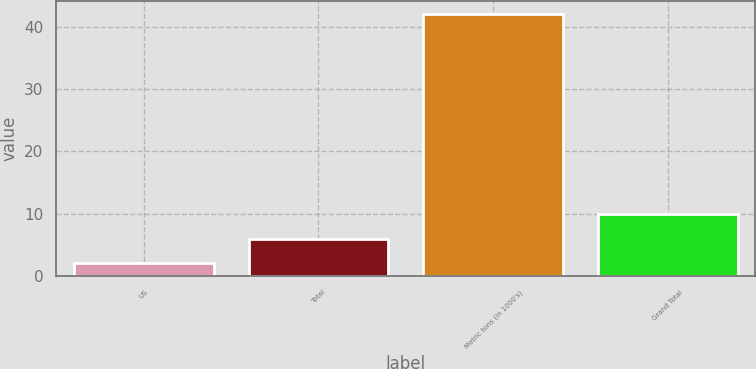<chart> <loc_0><loc_0><loc_500><loc_500><bar_chart><fcel>US<fcel>Total<fcel>Metric tons (in 1000's)<fcel>Grand Total<nl><fcel>2<fcel>6<fcel>42<fcel>10<nl></chart> 